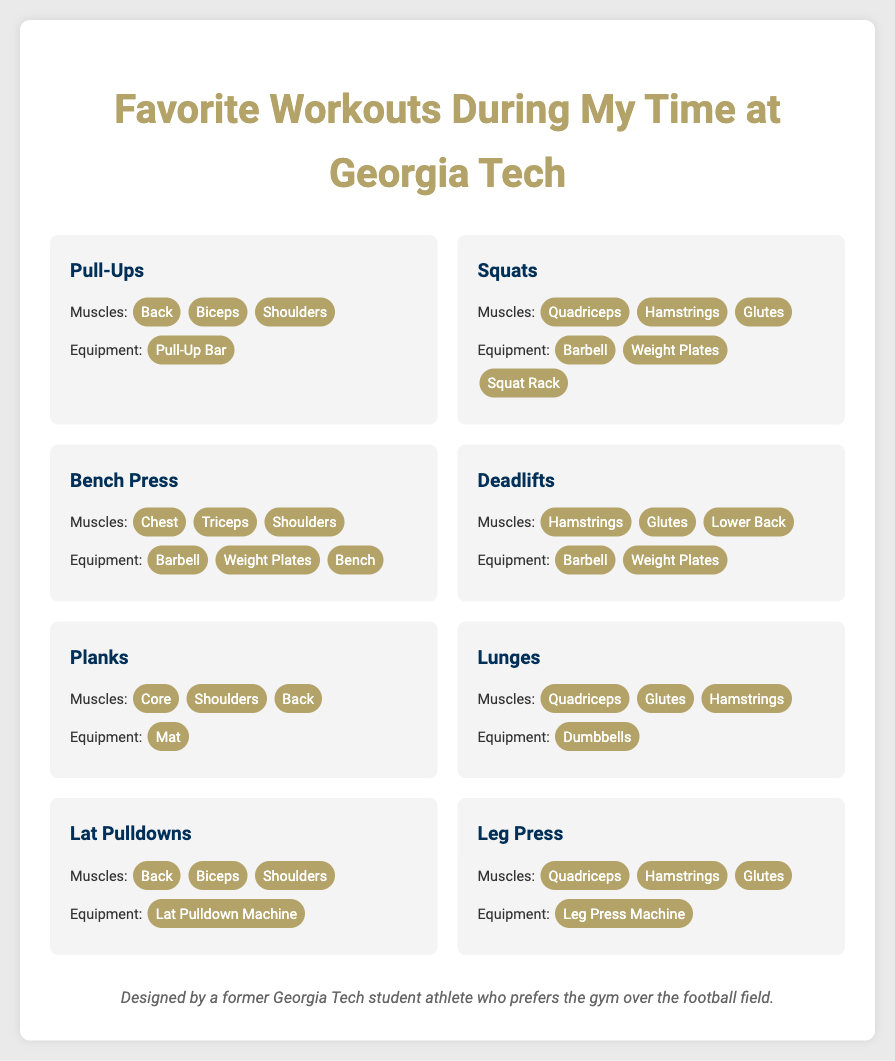What is the first workout listed? The first workout mentioned in the document is "Pull-Ups."
Answer: Pull-Ups How many muscle groups are targeted by Squats? Squats target three muscle groups: Quadriceps, Hamstrings, and Glutes.
Answer: Three What equipment is needed for Deadlifts? For Deadlifts, the equipment required is a Barbell and Weight Plates.
Answer: Barbell, Weight Plates Which workout targets the Core muscle group? The workout that targets the Core muscle group is "Planks."
Answer: Planks Which muscle group is not targeted by Lunges? The muscle group not targeted by Lunges is the Back.
Answer: Back What is the primary equipment used for Lat Pulldowns? The primary equipment used for Lat Pulldowns is the Lat Pulldown Machine.
Answer: Lat Pulldown Machine How many workouts listed target the Glutes muscle group? There are three workouts that target the Glutes muscle group: Squats, Lunges, and Leg Press.
Answer: Three Which workout targets both the Chest and Triceps? The workout that targets both the Chest and Triceps is "Bench Press."
Answer: Bench Press 